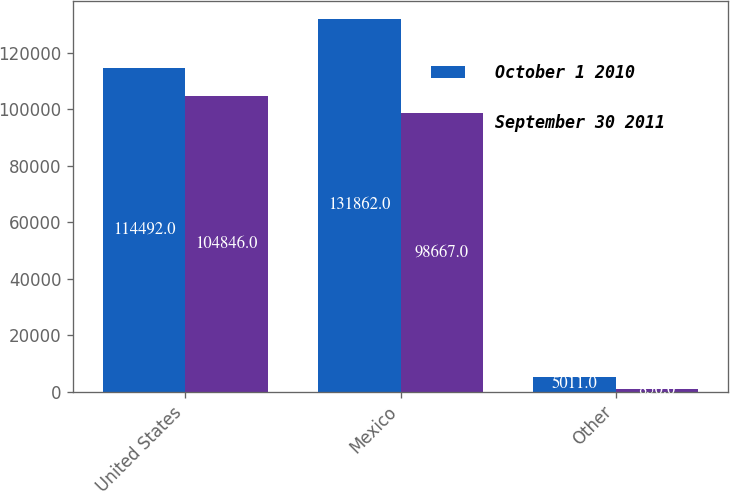Convert chart to OTSL. <chart><loc_0><loc_0><loc_500><loc_500><stacked_bar_chart><ecel><fcel>United States<fcel>Mexico<fcel>Other<nl><fcel>October 1 2010<fcel>114492<fcel>131862<fcel>5011<nl><fcel>September 30 2011<fcel>104846<fcel>98667<fcel>850<nl></chart> 